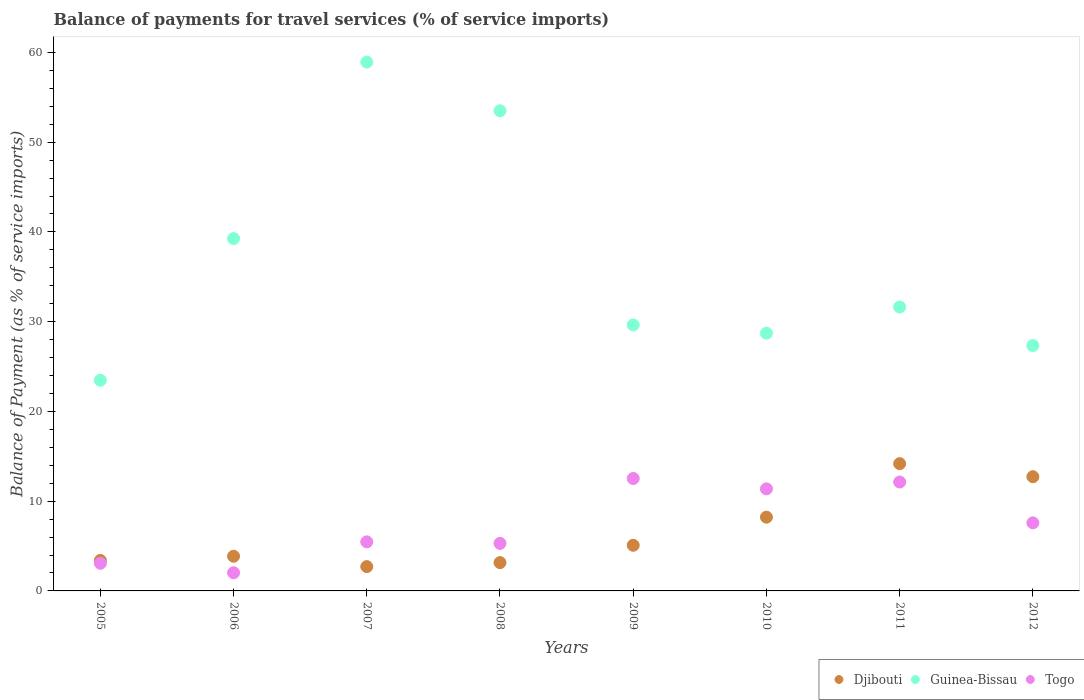How many different coloured dotlines are there?
Make the answer very short. 3. What is the balance of payments for travel services in Djibouti in 2006?
Offer a terse response. 3.86. Across all years, what is the maximum balance of payments for travel services in Togo?
Provide a succinct answer. 12.53. Across all years, what is the minimum balance of payments for travel services in Togo?
Offer a very short reply. 2.03. In which year was the balance of payments for travel services in Guinea-Bissau maximum?
Your answer should be compact. 2007. In which year was the balance of payments for travel services in Djibouti minimum?
Keep it short and to the point. 2007. What is the total balance of payments for travel services in Djibouti in the graph?
Your response must be concise. 53.34. What is the difference between the balance of payments for travel services in Djibouti in 2006 and that in 2009?
Your answer should be compact. -1.22. What is the difference between the balance of payments for travel services in Togo in 2011 and the balance of payments for travel services in Djibouti in 2007?
Keep it short and to the point. 9.43. What is the average balance of payments for travel services in Guinea-Bissau per year?
Offer a terse response. 36.56. In the year 2011, what is the difference between the balance of payments for travel services in Togo and balance of payments for travel services in Guinea-Bissau?
Offer a terse response. -19.5. In how many years, is the balance of payments for travel services in Guinea-Bissau greater than 36 %?
Offer a terse response. 3. What is the ratio of the balance of payments for travel services in Togo in 2008 to that in 2012?
Provide a short and direct response. 0.7. Is the balance of payments for travel services in Togo in 2005 less than that in 2006?
Offer a very short reply. No. What is the difference between the highest and the second highest balance of payments for travel services in Djibouti?
Provide a succinct answer. 1.45. What is the difference between the highest and the lowest balance of payments for travel services in Guinea-Bissau?
Ensure brevity in your answer.  35.45. In how many years, is the balance of payments for travel services in Togo greater than the average balance of payments for travel services in Togo taken over all years?
Provide a succinct answer. 4. Is the sum of the balance of payments for travel services in Togo in 2005 and 2009 greater than the maximum balance of payments for travel services in Djibouti across all years?
Make the answer very short. Yes. Is it the case that in every year, the sum of the balance of payments for travel services in Djibouti and balance of payments for travel services in Togo  is greater than the balance of payments for travel services in Guinea-Bissau?
Provide a succinct answer. No. Does the balance of payments for travel services in Togo monotonically increase over the years?
Give a very brief answer. No. Is the balance of payments for travel services in Guinea-Bissau strictly greater than the balance of payments for travel services in Djibouti over the years?
Make the answer very short. Yes. Is the balance of payments for travel services in Djibouti strictly less than the balance of payments for travel services in Togo over the years?
Offer a very short reply. No. How many dotlines are there?
Offer a very short reply. 3. Are the values on the major ticks of Y-axis written in scientific E-notation?
Offer a very short reply. No. Where does the legend appear in the graph?
Make the answer very short. Bottom right. How are the legend labels stacked?
Make the answer very short. Horizontal. What is the title of the graph?
Your response must be concise. Balance of payments for travel services (% of service imports). What is the label or title of the Y-axis?
Keep it short and to the point. Balance of Payment (as % of service imports). What is the Balance of Payment (as % of service imports) in Djibouti in 2005?
Make the answer very short. 3.4. What is the Balance of Payment (as % of service imports) in Guinea-Bissau in 2005?
Offer a terse response. 23.48. What is the Balance of Payment (as % of service imports) of Togo in 2005?
Give a very brief answer. 3.08. What is the Balance of Payment (as % of service imports) of Djibouti in 2006?
Your answer should be very brief. 3.86. What is the Balance of Payment (as % of service imports) of Guinea-Bissau in 2006?
Provide a short and direct response. 39.26. What is the Balance of Payment (as % of service imports) in Togo in 2006?
Your answer should be very brief. 2.03. What is the Balance of Payment (as % of service imports) in Djibouti in 2007?
Give a very brief answer. 2.71. What is the Balance of Payment (as % of service imports) of Guinea-Bissau in 2007?
Provide a succinct answer. 58.92. What is the Balance of Payment (as % of service imports) of Togo in 2007?
Your answer should be compact. 5.47. What is the Balance of Payment (as % of service imports) in Djibouti in 2008?
Your response must be concise. 3.15. What is the Balance of Payment (as % of service imports) in Guinea-Bissau in 2008?
Offer a very short reply. 53.5. What is the Balance of Payment (as % of service imports) of Togo in 2008?
Offer a very short reply. 5.3. What is the Balance of Payment (as % of service imports) in Djibouti in 2009?
Ensure brevity in your answer.  5.09. What is the Balance of Payment (as % of service imports) of Guinea-Bissau in 2009?
Your answer should be very brief. 29.64. What is the Balance of Payment (as % of service imports) in Togo in 2009?
Offer a terse response. 12.53. What is the Balance of Payment (as % of service imports) in Djibouti in 2010?
Make the answer very short. 8.22. What is the Balance of Payment (as % of service imports) in Guinea-Bissau in 2010?
Make the answer very short. 28.71. What is the Balance of Payment (as % of service imports) in Togo in 2010?
Provide a succinct answer. 11.37. What is the Balance of Payment (as % of service imports) of Djibouti in 2011?
Provide a short and direct response. 14.18. What is the Balance of Payment (as % of service imports) in Guinea-Bissau in 2011?
Provide a succinct answer. 31.64. What is the Balance of Payment (as % of service imports) of Togo in 2011?
Keep it short and to the point. 12.13. What is the Balance of Payment (as % of service imports) in Djibouti in 2012?
Offer a terse response. 12.73. What is the Balance of Payment (as % of service imports) in Guinea-Bissau in 2012?
Provide a succinct answer. 27.34. What is the Balance of Payment (as % of service imports) in Togo in 2012?
Make the answer very short. 7.59. Across all years, what is the maximum Balance of Payment (as % of service imports) of Djibouti?
Your response must be concise. 14.18. Across all years, what is the maximum Balance of Payment (as % of service imports) in Guinea-Bissau?
Provide a succinct answer. 58.92. Across all years, what is the maximum Balance of Payment (as % of service imports) in Togo?
Keep it short and to the point. 12.53. Across all years, what is the minimum Balance of Payment (as % of service imports) of Djibouti?
Your response must be concise. 2.71. Across all years, what is the minimum Balance of Payment (as % of service imports) of Guinea-Bissau?
Your answer should be compact. 23.48. Across all years, what is the minimum Balance of Payment (as % of service imports) of Togo?
Keep it short and to the point. 2.03. What is the total Balance of Payment (as % of service imports) in Djibouti in the graph?
Your answer should be compact. 53.34. What is the total Balance of Payment (as % of service imports) in Guinea-Bissau in the graph?
Offer a very short reply. 292.49. What is the total Balance of Payment (as % of service imports) in Togo in the graph?
Keep it short and to the point. 59.49. What is the difference between the Balance of Payment (as % of service imports) in Djibouti in 2005 and that in 2006?
Give a very brief answer. -0.47. What is the difference between the Balance of Payment (as % of service imports) in Guinea-Bissau in 2005 and that in 2006?
Ensure brevity in your answer.  -15.78. What is the difference between the Balance of Payment (as % of service imports) in Togo in 2005 and that in 2006?
Provide a short and direct response. 1.06. What is the difference between the Balance of Payment (as % of service imports) in Djibouti in 2005 and that in 2007?
Give a very brief answer. 0.69. What is the difference between the Balance of Payment (as % of service imports) in Guinea-Bissau in 2005 and that in 2007?
Your answer should be compact. -35.45. What is the difference between the Balance of Payment (as % of service imports) in Togo in 2005 and that in 2007?
Offer a terse response. -2.39. What is the difference between the Balance of Payment (as % of service imports) of Djibouti in 2005 and that in 2008?
Keep it short and to the point. 0.24. What is the difference between the Balance of Payment (as % of service imports) in Guinea-Bissau in 2005 and that in 2008?
Keep it short and to the point. -30.02. What is the difference between the Balance of Payment (as % of service imports) in Togo in 2005 and that in 2008?
Your answer should be very brief. -2.22. What is the difference between the Balance of Payment (as % of service imports) in Djibouti in 2005 and that in 2009?
Ensure brevity in your answer.  -1.69. What is the difference between the Balance of Payment (as % of service imports) in Guinea-Bissau in 2005 and that in 2009?
Provide a succinct answer. -6.16. What is the difference between the Balance of Payment (as % of service imports) of Togo in 2005 and that in 2009?
Offer a very short reply. -9.45. What is the difference between the Balance of Payment (as % of service imports) in Djibouti in 2005 and that in 2010?
Your answer should be very brief. -4.82. What is the difference between the Balance of Payment (as % of service imports) of Guinea-Bissau in 2005 and that in 2010?
Provide a short and direct response. -5.24. What is the difference between the Balance of Payment (as % of service imports) in Togo in 2005 and that in 2010?
Your answer should be very brief. -8.29. What is the difference between the Balance of Payment (as % of service imports) in Djibouti in 2005 and that in 2011?
Your answer should be very brief. -10.78. What is the difference between the Balance of Payment (as % of service imports) in Guinea-Bissau in 2005 and that in 2011?
Make the answer very short. -8.16. What is the difference between the Balance of Payment (as % of service imports) in Togo in 2005 and that in 2011?
Your answer should be compact. -9.05. What is the difference between the Balance of Payment (as % of service imports) in Djibouti in 2005 and that in 2012?
Offer a very short reply. -9.33. What is the difference between the Balance of Payment (as % of service imports) of Guinea-Bissau in 2005 and that in 2012?
Keep it short and to the point. -3.87. What is the difference between the Balance of Payment (as % of service imports) in Togo in 2005 and that in 2012?
Offer a very short reply. -4.51. What is the difference between the Balance of Payment (as % of service imports) in Djibouti in 2006 and that in 2007?
Your answer should be compact. 1.16. What is the difference between the Balance of Payment (as % of service imports) of Guinea-Bissau in 2006 and that in 2007?
Keep it short and to the point. -19.66. What is the difference between the Balance of Payment (as % of service imports) in Togo in 2006 and that in 2007?
Keep it short and to the point. -3.44. What is the difference between the Balance of Payment (as % of service imports) of Djibouti in 2006 and that in 2008?
Your response must be concise. 0.71. What is the difference between the Balance of Payment (as % of service imports) in Guinea-Bissau in 2006 and that in 2008?
Ensure brevity in your answer.  -14.24. What is the difference between the Balance of Payment (as % of service imports) of Togo in 2006 and that in 2008?
Provide a succinct answer. -3.27. What is the difference between the Balance of Payment (as % of service imports) of Djibouti in 2006 and that in 2009?
Provide a succinct answer. -1.22. What is the difference between the Balance of Payment (as % of service imports) in Guinea-Bissau in 2006 and that in 2009?
Keep it short and to the point. 9.62. What is the difference between the Balance of Payment (as % of service imports) in Togo in 2006 and that in 2009?
Give a very brief answer. -10.5. What is the difference between the Balance of Payment (as % of service imports) of Djibouti in 2006 and that in 2010?
Offer a very short reply. -4.36. What is the difference between the Balance of Payment (as % of service imports) in Guinea-Bissau in 2006 and that in 2010?
Your response must be concise. 10.55. What is the difference between the Balance of Payment (as % of service imports) in Togo in 2006 and that in 2010?
Provide a succinct answer. -9.35. What is the difference between the Balance of Payment (as % of service imports) of Djibouti in 2006 and that in 2011?
Ensure brevity in your answer.  -10.32. What is the difference between the Balance of Payment (as % of service imports) in Guinea-Bissau in 2006 and that in 2011?
Your response must be concise. 7.62. What is the difference between the Balance of Payment (as % of service imports) in Togo in 2006 and that in 2011?
Offer a very short reply. -10.11. What is the difference between the Balance of Payment (as % of service imports) of Djibouti in 2006 and that in 2012?
Your response must be concise. -8.86. What is the difference between the Balance of Payment (as % of service imports) in Guinea-Bissau in 2006 and that in 2012?
Offer a terse response. 11.92. What is the difference between the Balance of Payment (as % of service imports) of Togo in 2006 and that in 2012?
Offer a very short reply. -5.56. What is the difference between the Balance of Payment (as % of service imports) in Djibouti in 2007 and that in 2008?
Your answer should be very brief. -0.45. What is the difference between the Balance of Payment (as % of service imports) of Guinea-Bissau in 2007 and that in 2008?
Your answer should be very brief. 5.43. What is the difference between the Balance of Payment (as % of service imports) of Togo in 2007 and that in 2008?
Your response must be concise. 0.17. What is the difference between the Balance of Payment (as % of service imports) in Djibouti in 2007 and that in 2009?
Ensure brevity in your answer.  -2.38. What is the difference between the Balance of Payment (as % of service imports) of Guinea-Bissau in 2007 and that in 2009?
Ensure brevity in your answer.  29.29. What is the difference between the Balance of Payment (as % of service imports) of Togo in 2007 and that in 2009?
Your answer should be very brief. -7.06. What is the difference between the Balance of Payment (as % of service imports) in Djibouti in 2007 and that in 2010?
Your answer should be compact. -5.51. What is the difference between the Balance of Payment (as % of service imports) of Guinea-Bissau in 2007 and that in 2010?
Your answer should be compact. 30.21. What is the difference between the Balance of Payment (as % of service imports) in Togo in 2007 and that in 2010?
Keep it short and to the point. -5.91. What is the difference between the Balance of Payment (as % of service imports) in Djibouti in 2007 and that in 2011?
Your answer should be very brief. -11.47. What is the difference between the Balance of Payment (as % of service imports) in Guinea-Bissau in 2007 and that in 2011?
Make the answer very short. 27.29. What is the difference between the Balance of Payment (as % of service imports) in Togo in 2007 and that in 2011?
Keep it short and to the point. -6.67. What is the difference between the Balance of Payment (as % of service imports) in Djibouti in 2007 and that in 2012?
Offer a terse response. -10.02. What is the difference between the Balance of Payment (as % of service imports) in Guinea-Bissau in 2007 and that in 2012?
Offer a very short reply. 31.58. What is the difference between the Balance of Payment (as % of service imports) in Togo in 2007 and that in 2012?
Your answer should be compact. -2.12. What is the difference between the Balance of Payment (as % of service imports) of Djibouti in 2008 and that in 2009?
Give a very brief answer. -1.93. What is the difference between the Balance of Payment (as % of service imports) of Guinea-Bissau in 2008 and that in 2009?
Your response must be concise. 23.86. What is the difference between the Balance of Payment (as % of service imports) of Togo in 2008 and that in 2009?
Keep it short and to the point. -7.23. What is the difference between the Balance of Payment (as % of service imports) in Djibouti in 2008 and that in 2010?
Give a very brief answer. -5.07. What is the difference between the Balance of Payment (as % of service imports) of Guinea-Bissau in 2008 and that in 2010?
Ensure brevity in your answer.  24.78. What is the difference between the Balance of Payment (as % of service imports) of Togo in 2008 and that in 2010?
Provide a short and direct response. -6.08. What is the difference between the Balance of Payment (as % of service imports) of Djibouti in 2008 and that in 2011?
Your answer should be compact. -11.03. What is the difference between the Balance of Payment (as % of service imports) in Guinea-Bissau in 2008 and that in 2011?
Your response must be concise. 21.86. What is the difference between the Balance of Payment (as % of service imports) of Togo in 2008 and that in 2011?
Provide a succinct answer. -6.84. What is the difference between the Balance of Payment (as % of service imports) in Djibouti in 2008 and that in 2012?
Your answer should be compact. -9.57. What is the difference between the Balance of Payment (as % of service imports) in Guinea-Bissau in 2008 and that in 2012?
Keep it short and to the point. 26.16. What is the difference between the Balance of Payment (as % of service imports) of Togo in 2008 and that in 2012?
Provide a short and direct response. -2.29. What is the difference between the Balance of Payment (as % of service imports) in Djibouti in 2009 and that in 2010?
Your answer should be compact. -3.13. What is the difference between the Balance of Payment (as % of service imports) in Guinea-Bissau in 2009 and that in 2010?
Make the answer very short. 0.92. What is the difference between the Balance of Payment (as % of service imports) of Togo in 2009 and that in 2010?
Your answer should be compact. 1.15. What is the difference between the Balance of Payment (as % of service imports) in Djibouti in 2009 and that in 2011?
Your answer should be very brief. -9.09. What is the difference between the Balance of Payment (as % of service imports) in Guinea-Bissau in 2009 and that in 2011?
Provide a succinct answer. -2. What is the difference between the Balance of Payment (as % of service imports) of Togo in 2009 and that in 2011?
Your answer should be very brief. 0.39. What is the difference between the Balance of Payment (as % of service imports) of Djibouti in 2009 and that in 2012?
Your answer should be very brief. -7.64. What is the difference between the Balance of Payment (as % of service imports) of Guinea-Bissau in 2009 and that in 2012?
Give a very brief answer. 2.3. What is the difference between the Balance of Payment (as % of service imports) of Togo in 2009 and that in 2012?
Your answer should be compact. 4.94. What is the difference between the Balance of Payment (as % of service imports) in Djibouti in 2010 and that in 2011?
Your response must be concise. -5.96. What is the difference between the Balance of Payment (as % of service imports) of Guinea-Bissau in 2010 and that in 2011?
Offer a very short reply. -2.92. What is the difference between the Balance of Payment (as % of service imports) in Togo in 2010 and that in 2011?
Ensure brevity in your answer.  -0.76. What is the difference between the Balance of Payment (as % of service imports) of Djibouti in 2010 and that in 2012?
Offer a very short reply. -4.51. What is the difference between the Balance of Payment (as % of service imports) in Guinea-Bissau in 2010 and that in 2012?
Ensure brevity in your answer.  1.37. What is the difference between the Balance of Payment (as % of service imports) of Togo in 2010 and that in 2012?
Keep it short and to the point. 3.79. What is the difference between the Balance of Payment (as % of service imports) of Djibouti in 2011 and that in 2012?
Your response must be concise. 1.45. What is the difference between the Balance of Payment (as % of service imports) in Guinea-Bissau in 2011 and that in 2012?
Provide a short and direct response. 4.29. What is the difference between the Balance of Payment (as % of service imports) in Togo in 2011 and that in 2012?
Offer a very short reply. 4.55. What is the difference between the Balance of Payment (as % of service imports) of Djibouti in 2005 and the Balance of Payment (as % of service imports) of Guinea-Bissau in 2006?
Your answer should be compact. -35.86. What is the difference between the Balance of Payment (as % of service imports) of Djibouti in 2005 and the Balance of Payment (as % of service imports) of Togo in 2006?
Keep it short and to the point. 1.37. What is the difference between the Balance of Payment (as % of service imports) of Guinea-Bissau in 2005 and the Balance of Payment (as % of service imports) of Togo in 2006?
Your answer should be compact. 21.45. What is the difference between the Balance of Payment (as % of service imports) in Djibouti in 2005 and the Balance of Payment (as % of service imports) in Guinea-Bissau in 2007?
Provide a short and direct response. -55.53. What is the difference between the Balance of Payment (as % of service imports) in Djibouti in 2005 and the Balance of Payment (as % of service imports) in Togo in 2007?
Ensure brevity in your answer.  -2.07. What is the difference between the Balance of Payment (as % of service imports) of Guinea-Bissau in 2005 and the Balance of Payment (as % of service imports) of Togo in 2007?
Your answer should be compact. 18.01. What is the difference between the Balance of Payment (as % of service imports) in Djibouti in 2005 and the Balance of Payment (as % of service imports) in Guinea-Bissau in 2008?
Offer a very short reply. -50.1. What is the difference between the Balance of Payment (as % of service imports) in Djibouti in 2005 and the Balance of Payment (as % of service imports) in Togo in 2008?
Offer a terse response. -1.9. What is the difference between the Balance of Payment (as % of service imports) in Guinea-Bissau in 2005 and the Balance of Payment (as % of service imports) in Togo in 2008?
Give a very brief answer. 18.18. What is the difference between the Balance of Payment (as % of service imports) of Djibouti in 2005 and the Balance of Payment (as % of service imports) of Guinea-Bissau in 2009?
Your answer should be compact. -26.24. What is the difference between the Balance of Payment (as % of service imports) in Djibouti in 2005 and the Balance of Payment (as % of service imports) in Togo in 2009?
Make the answer very short. -9.13. What is the difference between the Balance of Payment (as % of service imports) in Guinea-Bissau in 2005 and the Balance of Payment (as % of service imports) in Togo in 2009?
Give a very brief answer. 10.95. What is the difference between the Balance of Payment (as % of service imports) of Djibouti in 2005 and the Balance of Payment (as % of service imports) of Guinea-Bissau in 2010?
Give a very brief answer. -25.32. What is the difference between the Balance of Payment (as % of service imports) in Djibouti in 2005 and the Balance of Payment (as % of service imports) in Togo in 2010?
Offer a terse response. -7.98. What is the difference between the Balance of Payment (as % of service imports) in Guinea-Bissau in 2005 and the Balance of Payment (as % of service imports) in Togo in 2010?
Ensure brevity in your answer.  12.1. What is the difference between the Balance of Payment (as % of service imports) in Djibouti in 2005 and the Balance of Payment (as % of service imports) in Guinea-Bissau in 2011?
Your answer should be very brief. -28.24. What is the difference between the Balance of Payment (as % of service imports) in Djibouti in 2005 and the Balance of Payment (as % of service imports) in Togo in 2011?
Your answer should be very brief. -8.74. What is the difference between the Balance of Payment (as % of service imports) in Guinea-Bissau in 2005 and the Balance of Payment (as % of service imports) in Togo in 2011?
Your response must be concise. 11.34. What is the difference between the Balance of Payment (as % of service imports) in Djibouti in 2005 and the Balance of Payment (as % of service imports) in Guinea-Bissau in 2012?
Offer a very short reply. -23.95. What is the difference between the Balance of Payment (as % of service imports) of Djibouti in 2005 and the Balance of Payment (as % of service imports) of Togo in 2012?
Provide a succinct answer. -4.19. What is the difference between the Balance of Payment (as % of service imports) of Guinea-Bissau in 2005 and the Balance of Payment (as % of service imports) of Togo in 2012?
Provide a short and direct response. 15.89. What is the difference between the Balance of Payment (as % of service imports) of Djibouti in 2006 and the Balance of Payment (as % of service imports) of Guinea-Bissau in 2007?
Ensure brevity in your answer.  -55.06. What is the difference between the Balance of Payment (as % of service imports) of Djibouti in 2006 and the Balance of Payment (as % of service imports) of Togo in 2007?
Provide a short and direct response. -1.6. What is the difference between the Balance of Payment (as % of service imports) in Guinea-Bissau in 2006 and the Balance of Payment (as % of service imports) in Togo in 2007?
Keep it short and to the point. 33.79. What is the difference between the Balance of Payment (as % of service imports) in Djibouti in 2006 and the Balance of Payment (as % of service imports) in Guinea-Bissau in 2008?
Provide a short and direct response. -49.63. What is the difference between the Balance of Payment (as % of service imports) of Djibouti in 2006 and the Balance of Payment (as % of service imports) of Togo in 2008?
Keep it short and to the point. -1.43. What is the difference between the Balance of Payment (as % of service imports) of Guinea-Bissau in 2006 and the Balance of Payment (as % of service imports) of Togo in 2008?
Keep it short and to the point. 33.96. What is the difference between the Balance of Payment (as % of service imports) of Djibouti in 2006 and the Balance of Payment (as % of service imports) of Guinea-Bissau in 2009?
Provide a short and direct response. -25.77. What is the difference between the Balance of Payment (as % of service imports) of Djibouti in 2006 and the Balance of Payment (as % of service imports) of Togo in 2009?
Make the answer very short. -8.66. What is the difference between the Balance of Payment (as % of service imports) in Guinea-Bissau in 2006 and the Balance of Payment (as % of service imports) in Togo in 2009?
Give a very brief answer. 26.73. What is the difference between the Balance of Payment (as % of service imports) in Djibouti in 2006 and the Balance of Payment (as % of service imports) in Guinea-Bissau in 2010?
Your answer should be compact. -24.85. What is the difference between the Balance of Payment (as % of service imports) in Djibouti in 2006 and the Balance of Payment (as % of service imports) in Togo in 2010?
Make the answer very short. -7.51. What is the difference between the Balance of Payment (as % of service imports) of Guinea-Bissau in 2006 and the Balance of Payment (as % of service imports) of Togo in 2010?
Provide a short and direct response. 27.89. What is the difference between the Balance of Payment (as % of service imports) in Djibouti in 2006 and the Balance of Payment (as % of service imports) in Guinea-Bissau in 2011?
Provide a short and direct response. -27.77. What is the difference between the Balance of Payment (as % of service imports) in Djibouti in 2006 and the Balance of Payment (as % of service imports) in Togo in 2011?
Your response must be concise. -8.27. What is the difference between the Balance of Payment (as % of service imports) in Guinea-Bissau in 2006 and the Balance of Payment (as % of service imports) in Togo in 2011?
Your answer should be very brief. 27.13. What is the difference between the Balance of Payment (as % of service imports) of Djibouti in 2006 and the Balance of Payment (as % of service imports) of Guinea-Bissau in 2012?
Provide a succinct answer. -23.48. What is the difference between the Balance of Payment (as % of service imports) in Djibouti in 2006 and the Balance of Payment (as % of service imports) in Togo in 2012?
Give a very brief answer. -3.72. What is the difference between the Balance of Payment (as % of service imports) in Guinea-Bissau in 2006 and the Balance of Payment (as % of service imports) in Togo in 2012?
Your answer should be very brief. 31.67. What is the difference between the Balance of Payment (as % of service imports) in Djibouti in 2007 and the Balance of Payment (as % of service imports) in Guinea-Bissau in 2008?
Make the answer very short. -50.79. What is the difference between the Balance of Payment (as % of service imports) in Djibouti in 2007 and the Balance of Payment (as % of service imports) in Togo in 2008?
Keep it short and to the point. -2.59. What is the difference between the Balance of Payment (as % of service imports) of Guinea-Bissau in 2007 and the Balance of Payment (as % of service imports) of Togo in 2008?
Offer a terse response. 53.63. What is the difference between the Balance of Payment (as % of service imports) in Djibouti in 2007 and the Balance of Payment (as % of service imports) in Guinea-Bissau in 2009?
Your response must be concise. -26.93. What is the difference between the Balance of Payment (as % of service imports) in Djibouti in 2007 and the Balance of Payment (as % of service imports) in Togo in 2009?
Provide a succinct answer. -9.82. What is the difference between the Balance of Payment (as % of service imports) of Guinea-Bissau in 2007 and the Balance of Payment (as % of service imports) of Togo in 2009?
Make the answer very short. 46.4. What is the difference between the Balance of Payment (as % of service imports) in Djibouti in 2007 and the Balance of Payment (as % of service imports) in Guinea-Bissau in 2010?
Your response must be concise. -26.01. What is the difference between the Balance of Payment (as % of service imports) of Djibouti in 2007 and the Balance of Payment (as % of service imports) of Togo in 2010?
Your answer should be very brief. -8.67. What is the difference between the Balance of Payment (as % of service imports) in Guinea-Bissau in 2007 and the Balance of Payment (as % of service imports) in Togo in 2010?
Make the answer very short. 47.55. What is the difference between the Balance of Payment (as % of service imports) in Djibouti in 2007 and the Balance of Payment (as % of service imports) in Guinea-Bissau in 2011?
Provide a short and direct response. -28.93. What is the difference between the Balance of Payment (as % of service imports) in Djibouti in 2007 and the Balance of Payment (as % of service imports) in Togo in 2011?
Offer a terse response. -9.43. What is the difference between the Balance of Payment (as % of service imports) of Guinea-Bissau in 2007 and the Balance of Payment (as % of service imports) of Togo in 2011?
Offer a very short reply. 46.79. What is the difference between the Balance of Payment (as % of service imports) in Djibouti in 2007 and the Balance of Payment (as % of service imports) in Guinea-Bissau in 2012?
Provide a short and direct response. -24.64. What is the difference between the Balance of Payment (as % of service imports) of Djibouti in 2007 and the Balance of Payment (as % of service imports) of Togo in 2012?
Offer a terse response. -4.88. What is the difference between the Balance of Payment (as % of service imports) in Guinea-Bissau in 2007 and the Balance of Payment (as % of service imports) in Togo in 2012?
Offer a terse response. 51.34. What is the difference between the Balance of Payment (as % of service imports) of Djibouti in 2008 and the Balance of Payment (as % of service imports) of Guinea-Bissau in 2009?
Your answer should be compact. -26.48. What is the difference between the Balance of Payment (as % of service imports) in Djibouti in 2008 and the Balance of Payment (as % of service imports) in Togo in 2009?
Offer a very short reply. -9.37. What is the difference between the Balance of Payment (as % of service imports) of Guinea-Bissau in 2008 and the Balance of Payment (as % of service imports) of Togo in 2009?
Make the answer very short. 40.97. What is the difference between the Balance of Payment (as % of service imports) of Djibouti in 2008 and the Balance of Payment (as % of service imports) of Guinea-Bissau in 2010?
Your response must be concise. -25.56. What is the difference between the Balance of Payment (as % of service imports) in Djibouti in 2008 and the Balance of Payment (as % of service imports) in Togo in 2010?
Offer a very short reply. -8.22. What is the difference between the Balance of Payment (as % of service imports) of Guinea-Bissau in 2008 and the Balance of Payment (as % of service imports) of Togo in 2010?
Give a very brief answer. 42.12. What is the difference between the Balance of Payment (as % of service imports) in Djibouti in 2008 and the Balance of Payment (as % of service imports) in Guinea-Bissau in 2011?
Make the answer very short. -28.48. What is the difference between the Balance of Payment (as % of service imports) of Djibouti in 2008 and the Balance of Payment (as % of service imports) of Togo in 2011?
Keep it short and to the point. -8.98. What is the difference between the Balance of Payment (as % of service imports) in Guinea-Bissau in 2008 and the Balance of Payment (as % of service imports) in Togo in 2011?
Offer a very short reply. 41.37. What is the difference between the Balance of Payment (as % of service imports) in Djibouti in 2008 and the Balance of Payment (as % of service imports) in Guinea-Bissau in 2012?
Your response must be concise. -24.19. What is the difference between the Balance of Payment (as % of service imports) in Djibouti in 2008 and the Balance of Payment (as % of service imports) in Togo in 2012?
Make the answer very short. -4.43. What is the difference between the Balance of Payment (as % of service imports) in Guinea-Bissau in 2008 and the Balance of Payment (as % of service imports) in Togo in 2012?
Your answer should be very brief. 45.91. What is the difference between the Balance of Payment (as % of service imports) in Djibouti in 2009 and the Balance of Payment (as % of service imports) in Guinea-Bissau in 2010?
Provide a short and direct response. -23.63. What is the difference between the Balance of Payment (as % of service imports) of Djibouti in 2009 and the Balance of Payment (as % of service imports) of Togo in 2010?
Your response must be concise. -6.29. What is the difference between the Balance of Payment (as % of service imports) in Guinea-Bissau in 2009 and the Balance of Payment (as % of service imports) in Togo in 2010?
Give a very brief answer. 18.26. What is the difference between the Balance of Payment (as % of service imports) in Djibouti in 2009 and the Balance of Payment (as % of service imports) in Guinea-Bissau in 2011?
Offer a terse response. -26.55. What is the difference between the Balance of Payment (as % of service imports) of Djibouti in 2009 and the Balance of Payment (as % of service imports) of Togo in 2011?
Keep it short and to the point. -7.05. What is the difference between the Balance of Payment (as % of service imports) of Guinea-Bissau in 2009 and the Balance of Payment (as % of service imports) of Togo in 2011?
Offer a very short reply. 17.51. What is the difference between the Balance of Payment (as % of service imports) in Djibouti in 2009 and the Balance of Payment (as % of service imports) in Guinea-Bissau in 2012?
Provide a short and direct response. -22.26. What is the difference between the Balance of Payment (as % of service imports) in Djibouti in 2009 and the Balance of Payment (as % of service imports) in Togo in 2012?
Ensure brevity in your answer.  -2.5. What is the difference between the Balance of Payment (as % of service imports) in Guinea-Bissau in 2009 and the Balance of Payment (as % of service imports) in Togo in 2012?
Keep it short and to the point. 22.05. What is the difference between the Balance of Payment (as % of service imports) in Djibouti in 2010 and the Balance of Payment (as % of service imports) in Guinea-Bissau in 2011?
Provide a succinct answer. -23.42. What is the difference between the Balance of Payment (as % of service imports) of Djibouti in 2010 and the Balance of Payment (as % of service imports) of Togo in 2011?
Make the answer very short. -3.91. What is the difference between the Balance of Payment (as % of service imports) in Guinea-Bissau in 2010 and the Balance of Payment (as % of service imports) in Togo in 2011?
Give a very brief answer. 16.58. What is the difference between the Balance of Payment (as % of service imports) of Djibouti in 2010 and the Balance of Payment (as % of service imports) of Guinea-Bissau in 2012?
Your answer should be compact. -19.12. What is the difference between the Balance of Payment (as % of service imports) of Djibouti in 2010 and the Balance of Payment (as % of service imports) of Togo in 2012?
Offer a terse response. 0.63. What is the difference between the Balance of Payment (as % of service imports) of Guinea-Bissau in 2010 and the Balance of Payment (as % of service imports) of Togo in 2012?
Give a very brief answer. 21.13. What is the difference between the Balance of Payment (as % of service imports) in Djibouti in 2011 and the Balance of Payment (as % of service imports) in Guinea-Bissau in 2012?
Provide a succinct answer. -13.16. What is the difference between the Balance of Payment (as % of service imports) of Djibouti in 2011 and the Balance of Payment (as % of service imports) of Togo in 2012?
Your answer should be very brief. 6.59. What is the difference between the Balance of Payment (as % of service imports) of Guinea-Bissau in 2011 and the Balance of Payment (as % of service imports) of Togo in 2012?
Offer a terse response. 24.05. What is the average Balance of Payment (as % of service imports) of Djibouti per year?
Your answer should be very brief. 6.67. What is the average Balance of Payment (as % of service imports) of Guinea-Bissau per year?
Provide a short and direct response. 36.56. What is the average Balance of Payment (as % of service imports) of Togo per year?
Give a very brief answer. 7.44. In the year 2005, what is the difference between the Balance of Payment (as % of service imports) in Djibouti and Balance of Payment (as % of service imports) in Guinea-Bissau?
Your answer should be compact. -20.08. In the year 2005, what is the difference between the Balance of Payment (as % of service imports) of Djibouti and Balance of Payment (as % of service imports) of Togo?
Make the answer very short. 0.32. In the year 2005, what is the difference between the Balance of Payment (as % of service imports) in Guinea-Bissau and Balance of Payment (as % of service imports) in Togo?
Offer a very short reply. 20.4. In the year 2006, what is the difference between the Balance of Payment (as % of service imports) of Djibouti and Balance of Payment (as % of service imports) of Guinea-Bissau?
Your answer should be very brief. -35.4. In the year 2006, what is the difference between the Balance of Payment (as % of service imports) of Djibouti and Balance of Payment (as % of service imports) of Togo?
Make the answer very short. 1.84. In the year 2006, what is the difference between the Balance of Payment (as % of service imports) in Guinea-Bissau and Balance of Payment (as % of service imports) in Togo?
Offer a very short reply. 37.24. In the year 2007, what is the difference between the Balance of Payment (as % of service imports) of Djibouti and Balance of Payment (as % of service imports) of Guinea-Bissau?
Give a very brief answer. -56.22. In the year 2007, what is the difference between the Balance of Payment (as % of service imports) in Djibouti and Balance of Payment (as % of service imports) in Togo?
Make the answer very short. -2.76. In the year 2007, what is the difference between the Balance of Payment (as % of service imports) in Guinea-Bissau and Balance of Payment (as % of service imports) in Togo?
Ensure brevity in your answer.  53.46. In the year 2008, what is the difference between the Balance of Payment (as % of service imports) in Djibouti and Balance of Payment (as % of service imports) in Guinea-Bissau?
Make the answer very short. -50.34. In the year 2008, what is the difference between the Balance of Payment (as % of service imports) in Djibouti and Balance of Payment (as % of service imports) in Togo?
Your response must be concise. -2.14. In the year 2008, what is the difference between the Balance of Payment (as % of service imports) in Guinea-Bissau and Balance of Payment (as % of service imports) in Togo?
Offer a very short reply. 48.2. In the year 2009, what is the difference between the Balance of Payment (as % of service imports) of Djibouti and Balance of Payment (as % of service imports) of Guinea-Bissau?
Provide a succinct answer. -24.55. In the year 2009, what is the difference between the Balance of Payment (as % of service imports) in Djibouti and Balance of Payment (as % of service imports) in Togo?
Your answer should be very brief. -7.44. In the year 2009, what is the difference between the Balance of Payment (as % of service imports) of Guinea-Bissau and Balance of Payment (as % of service imports) of Togo?
Make the answer very short. 17.11. In the year 2010, what is the difference between the Balance of Payment (as % of service imports) in Djibouti and Balance of Payment (as % of service imports) in Guinea-Bissau?
Provide a short and direct response. -20.5. In the year 2010, what is the difference between the Balance of Payment (as % of service imports) of Djibouti and Balance of Payment (as % of service imports) of Togo?
Make the answer very short. -3.15. In the year 2010, what is the difference between the Balance of Payment (as % of service imports) in Guinea-Bissau and Balance of Payment (as % of service imports) in Togo?
Keep it short and to the point. 17.34. In the year 2011, what is the difference between the Balance of Payment (as % of service imports) of Djibouti and Balance of Payment (as % of service imports) of Guinea-Bissau?
Your answer should be very brief. -17.46. In the year 2011, what is the difference between the Balance of Payment (as % of service imports) of Djibouti and Balance of Payment (as % of service imports) of Togo?
Your answer should be very brief. 2.05. In the year 2011, what is the difference between the Balance of Payment (as % of service imports) in Guinea-Bissau and Balance of Payment (as % of service imports) in Togo?
Ensure brevity in your answer.  19.5. In the year 2012, what is the difference between the Balance of Payment (as % of service imports) of Djibouti and Balance of Payment (as % of service imports) of Guinea-Bissau?
Offer a terse response. -14.62. In the year 2012, what is the difference between the Balance of Payment (as % of service imports) in Djibouti and Balance of Payment (as % of service imports) in Togo?
Give a very brief answer. 5.14. In the year 2012, what is the difference between the Balance of Payment (as % of service imports) in Guinea-Bissau and Balance of Payment (as % of service imports) in Togo?
Ensure brevity in your answer.  19.76. What is the ratio of the Balance of Payment (as % of service imports) of Djibouti in 2005 to that in 2006?
Your answer should be compact. 0.88. What is the ratio of the Balance of Payment (as % of service imports) of Guinea-Bissau in 2005 to that in 2006?
Your response must be concise. 0.6. What is the ratio of the Balance of Payment (as % of service imports) in Togo in 2005 to that in 2006?
Your answer should be very brief. 1.52. What is the ratio of the Balance of Payment (as % of service imports) of Djibouti in 2005 to that in 2007?
Make the answer very short. 1.25. What is the ratio of the Balance of Payment (as % of service imports) in Guinea-Bissau in 2005 to that in 2007?
Offer a terse response. 0.4. What is the ratio of the Balance of Payment (as % of service imports) in Togo in 2005 to that in 2007?
Ensure brevity in your answer.  0.56. What is the ratio of the Balance of Payment (as % of service imports) of Djibouti in 2005 to that in 2008?
Keep it short and to the point. 1.08. What is the ratio of the Balance of Payment (as % of service imports) of Guinea-Bissau in 2005 to that in 2008?
Ensure brevity in your answer.  0.44. What is the ratio of the Balance of Payment (as % of service imports) in Togo in 2005 to that in 2008?
Offer a terse response. 0.58. What is the ratio of the Balance of Payment (as % of service imports) in Djibouti in 2005 to that in 2009?
Give a very brief answer. 0.67. What is the ratio of the Balance of Payment (as % of service imports) in Guinea-Bissau in 2005 to that in 2009?
Make the answer very short. 0.79. What is the ratio of the Balance of Payment (as % of service imports) of Togo in 2005 to that in 2009?
Provide a succinct answer. 0.25. What is the ratio of the Balance of Payment (as % of service imports) of Djibouti in 2005 to that in 2010?
Provide a short and direct response. 0.41. What is the ratio of the Balance of Payment (as % of service imports) in Guinea-Bissau in 2005 to that in 2010?
Offer a very short reply. 0.82. What is the ratio of the Balance of Payment (as % of service imports) of Togo in 2005 to that in 2010?
Provide a succinct answer. 0.27. What is the ratio of the Balance of Payment (as % of service imports) of Djibouti in 2005 to that in 2011?
Ensure brevity in your answer.  0.24. What is the ratio of the Balance of Payment (as % of service imports) in Guinea-Bissau in 2005 to that in 2011?
Offer a very short reply. 0.74. What is the ratio of the Balance of Payment (as % of service imports) in Togo in 2005 to that in 2011?
Provide a succinct answer. 0.25. What is the ratio of the Balance of Payment (as % of service imports) of Djibouti in 2005 to that in 2012?
Provide a short and direct response. 0.27. What is the ratio of the Balance of Payment (as % of service imports) of Guinea-Bissau in 2005 to that in 2012?
Keep it short and to the point. 0.86. What is the ratio of the Balance of Payment (as % of service imports) of Togo in 2005 to that in 2012?
Ensure brevity in your answer.  0.41. What is the ratio of the Balance of Payment (as % of service imports) of Djibouti in 2006 to that in 2007?
Provide a succinct answer. 1.43. What is the ratio of the Balance of Payment (as % of service imports) of Guinea-Bissau in 2006 to that in 2007?
Make the answer very short. 0.67. What is the ratio of the Balance of Payment (as % of service imports) of Togo in 2006 to that in 2007?
Your answer should be compact. 0.37. What is the ratio of the Balance of Payment (as % of service imports) of Djibouti in 2006 to that in 2008?
Provide a short and direct response. 1.23. What is the ratio of the Balance of Payment (as % of service imports) of Guinea-Bissau in 2006 to that in 2008?
Your response must be concise. 0.73. What is the ratio of the Balance of Payment (as % of service imports) of Togo in 2006 to that in 2008?
Keep it short and to the point. 0.38. What is the ratio of the Balance of Payment (as % of service imports) of Djibouti in 2006 to that in 2009?
Your response must be concise. 0.76. What is the ratio of the Balance of Payment (as % of service imports) in Guinea-Bissau in 2006 to that in 2009?
Your answer should be very brief. 1.32. What is the ratio of the Balance of Payment (as % of service imports) in Togo in 2006 to that in 2009?
Keep it short and to the point. 0.16. What is the ratio of the Balance of Payment (as % of service imports) in Djibouti in 2006 to that in 2010?
Ensure brevity in your answer.  0.47. What is the ratio of the Balance of Payment (as % of service imports) in Guinea-Bissau in 2006 to that in 2010?
Your response must be concise. 1.37. What is the ratio of the Balance of Payment (as % of service imports) in Togo in 2006 to that in 2010?
Ensure brevity in your answer.  0.18. What is the ratio of the Balance of Payment (as % of service imports) of Djibouti in 2006 to that in 2011?
Your answer should be very brief. 0.27. What is the ratio of the Balance of Payment (as % of service imports) of Guinea-Bissau in 2006 to that in 2011?
Your response must be concise. 1.24. What is the ratio of the Balance of Payment (as % of service imports) in Togo in 2006 to that in 2011?
Offer a very short reply. 0.17. What is the ratio of the Balance of Payment (as % of service imports) in Djibouti in 2006 to that in 2012?
Give a very brief answer. 0.3. What is the ratio of the Balance of Payment (as % of service imports) of Guinea-Bissau in 2006 to that in 2012?
Make the answer very short. 1.44. What is the ratio of the Balance of Payment (as % of service imports) of Togo in 2006 to that in 2012?
Your answer should be very brief. 0.27. What is the ratio of the Balance of Payment (as % of service imports) of Djibouti in 2007 to that in 2008?
Keep it short and to the point. 0.86. What is the ratio of the Balance of Payment (as % of service imports) of Guinea-Bissau in 2007 to that in 2008?
Give a very brief answer. 1.1. What is the ratio of the Balance of Payment (as % of service imports) in Togo in 2007 to that in 2008?
Your answer should be very brief. 1.03. What is the ratio of the Balance of Payment (as % of service imports) in Djibouti in 2007 to that in 2009?
Offer a very short reply. 0.53. What is the ratio of the Balance of Payment (as % of service imports) of Guinea-Bissau in 2007 to that in 2009?
Your answer should be very brief. 1.99. What is the ratio of the Balance of Payment (as % of service imports) in Togo in 2007 to that in 2009?
Offer a very short reply. 0.44. What is the ratio of the Balance of Payment (as % of service imports) in Djibouti in 2007 to that in 2010?
Make the answer very short. 0.33. What is the ratio of the Balance of Payment (as % of service imports) of Guinea-Bissau in 2007 to that in 2010?
Your answer should be very brief. 2.05. What is the ratio of the Balance of Payment (as % of service imports) in Togo in 2007 to that in 2010?
Give a very brief answer. 0.48. What is the ratio of the Balance of Payment (as % of service imports) in Djibouti in 2007 to that in 2011?
Your response must be concise. 0.19. What is the ratio of the Balance of Payment (as % of service imports) of Guinea-Bissau in 2007 to that in 2011?
Your response must be concise. 1.86. What is the ratio of the Balance of Payment (as % of service imports) in Togo in 2007 to that in 2011?
Keep it short and to the point. 0.45. What is the ratio of the Balance of Payment (as % of service imports) in Djibouti in 2007 to that in 2012?
Ensure brevity in your answer.  0.21. What is the ratio of the Balance of Payment (as % of service imports) in Guinea-Bissau in 2007 to that in 2012?
Give a very brief answer. 2.15. What is the ratio of the Balance of Payment (as % of service imports) of Togo in 2007 to that in 2012?
Your response must be concise. 0.72. What is the ratio of the Balance of Payment (as % of service imports) in Djibouti in 2008 to that in 2009?
Provide a short and direct response. 0.62. What is the ratio of the Balance of Payment (as % of service imports) in Guinea-Bissau in 2008 to that in 2009?
Offer a very short reply. 1.8. What is the ratio of the Balance of Payment (as % of service imports) of Togo in 2008 to that in 2009?
Your answer should be compact. 0.42. What is the ratio of the Balance of Payment (as % of service imports) of Djibouti in 2008 to that in 2010?
Provide a succinct answer. 0.38. What is the ratio of the Balance of Payment (as % of service imports) of Guinea-Bissau in 2008 to that in 2010?
Ensure brevity in your answer.  1.86. What is the ratio of the Balance of Payment (as % of service imports) of Togo in 2008 to that in 2010?
Provide a succinct answer. 0.47. What is the ratio of the Balance of Payment (as % of service imports) of Djibouti in 2008 to that in 2011?
Your response must be concise. 0.22. What is the ratio of the Balance of Payment (as % of service imports) of Guinea-Bissau in 2008 to that in 2011?
Provide a short and direct response. 1.69. What is the ratio of the Balance of Payment (as % of service imports) in Togo in 2008 to that in 2011?
Your response must be concise. 0.44. What is the ratio of the Balance of Payment (as % of service imports) of Djibouti in 2008 to that in 2012?
Your answer should be compact. 0.25. What is the ratio of the Balance of Payment (as % of service imports) in Guinea-Bissau in 2008 to that in 2012?
Offer a very short reply. 1.96. What is the ratio of the Balance of Payment (as % of service imports) in Togo in 2008 to that in 2012?
Provide a short and direct response. 0.7. What is the ratio of the Balance of Payment (as % of service imports) of Djibouti in 2009 to that in 2010?
Ensure brevity in your answer.  0.62. What is the ratio of the Balance of Payment (as % of service imports) of Guinea-Bissau in 2009 to that in 2010?
Your response must be concise. 1.03. What is the ratio of the Balance of Payment (as % of service imports) of Togo in 2009 to that in 2010?
Make the answer very short. 1.1. What is the ratio of the Balance of Payment (as % of service imports) in Djibouti in 2009 to that in 2011?
Provide a short and direct response. 0.36. What is the ratio of the Balance of Payment (as % of service imports) in Guinea-Bissau in 2009 to that in 2011?
Your response must be concise. 0.94. What is the ratio of the Balance of Payment (as % of service imports) of Togo in 2009 to that in 2011?
Make the answer very short. 1.03. What is the ratio of the Balance of Payment (as % of service imports) in Djibouti in 2009 to that in 2012?
Provide a succinct answer. 0.4. What is the ratio of the Balance of Payment (as % of service imports) in Guinea-Bissau in 2009 to that in 2012?
Offer a very short reply. 1.08. What is the ratio of the Balance of Payment (as % of service imports) of Togo in 2009 to that in 2012?
Provide a succinct answer. 1.65. What is the ratio of the Balance of Payment (as % of service imports) in Djibouti in 2010 to that in 2011?
Provide a short and direct response. 0.58. What is the ratio of the Balance of Payment (as % of service imports) in Guinea-Bissau in 2010 to that in 2011?
Your answer should be very brief. 0.91. What is the ratio of the Balance of Payment (as % of service imports) of Togo in 2010 to that in 2011?
Offer a terse response. 0.94. What is the ratio of the Balance of Payment (as % of service imports) of Djibouti in 2010 to that in 2012?
Your answer should be compact. 0.65. What is the ratio of the Balance of Payment (as % of service imports) of Guinea-Bissau in 2010 to that in 2012?
Provide a succinct answer. 1.05. What is the ratio of the Balance of Payment (as % of service imports) in Togo in 2010 to that in 2012?
Give a very brief answer. 1.5. What is the ratio of the Balance of Payment (as % of service imports) in Djibouti in 2011 to that in 2012?
Provide a short and direct response. 1.11. What is the ratio of the Balance of Payment (as % of service imports) in Guinea-Bissau in 2011 to that in 2012?
Your response must be concise. 1.16. What is the ratio of the Balance of Payment (as % of service imports) of Togo in 2011 to that in 2012?
Your answer should be very brief. 1.6. What is the difference between the highest and the second highest Balance of Payment (as % of service imports) of Djibouti?
Offer a terse response. 1.45. What is the difference between the highest and the second highest Balance of Payment (as % of service imports) in Guinea-Bissau?
Your answer should be very brief. 5.43. What is the difference between the highest and the second highest Balance of Payment (as % of service imports) of Togo?
Offer a terse response. 0.39. What is the difference between the highest and the lowest Balance of Payment (as % of service imports) in Djibouti?
Keep it short and to the point. 11.47. What is the difference between the highest and the lowest Balance of Payment (as % of service imports) in Guinea-Bissau?
Your answer should be compact. 35.45. What is the difference between the highest and the lowest Balance of Payment (as % of service imports) of Togo?
Offer a terse response. 10.5. 